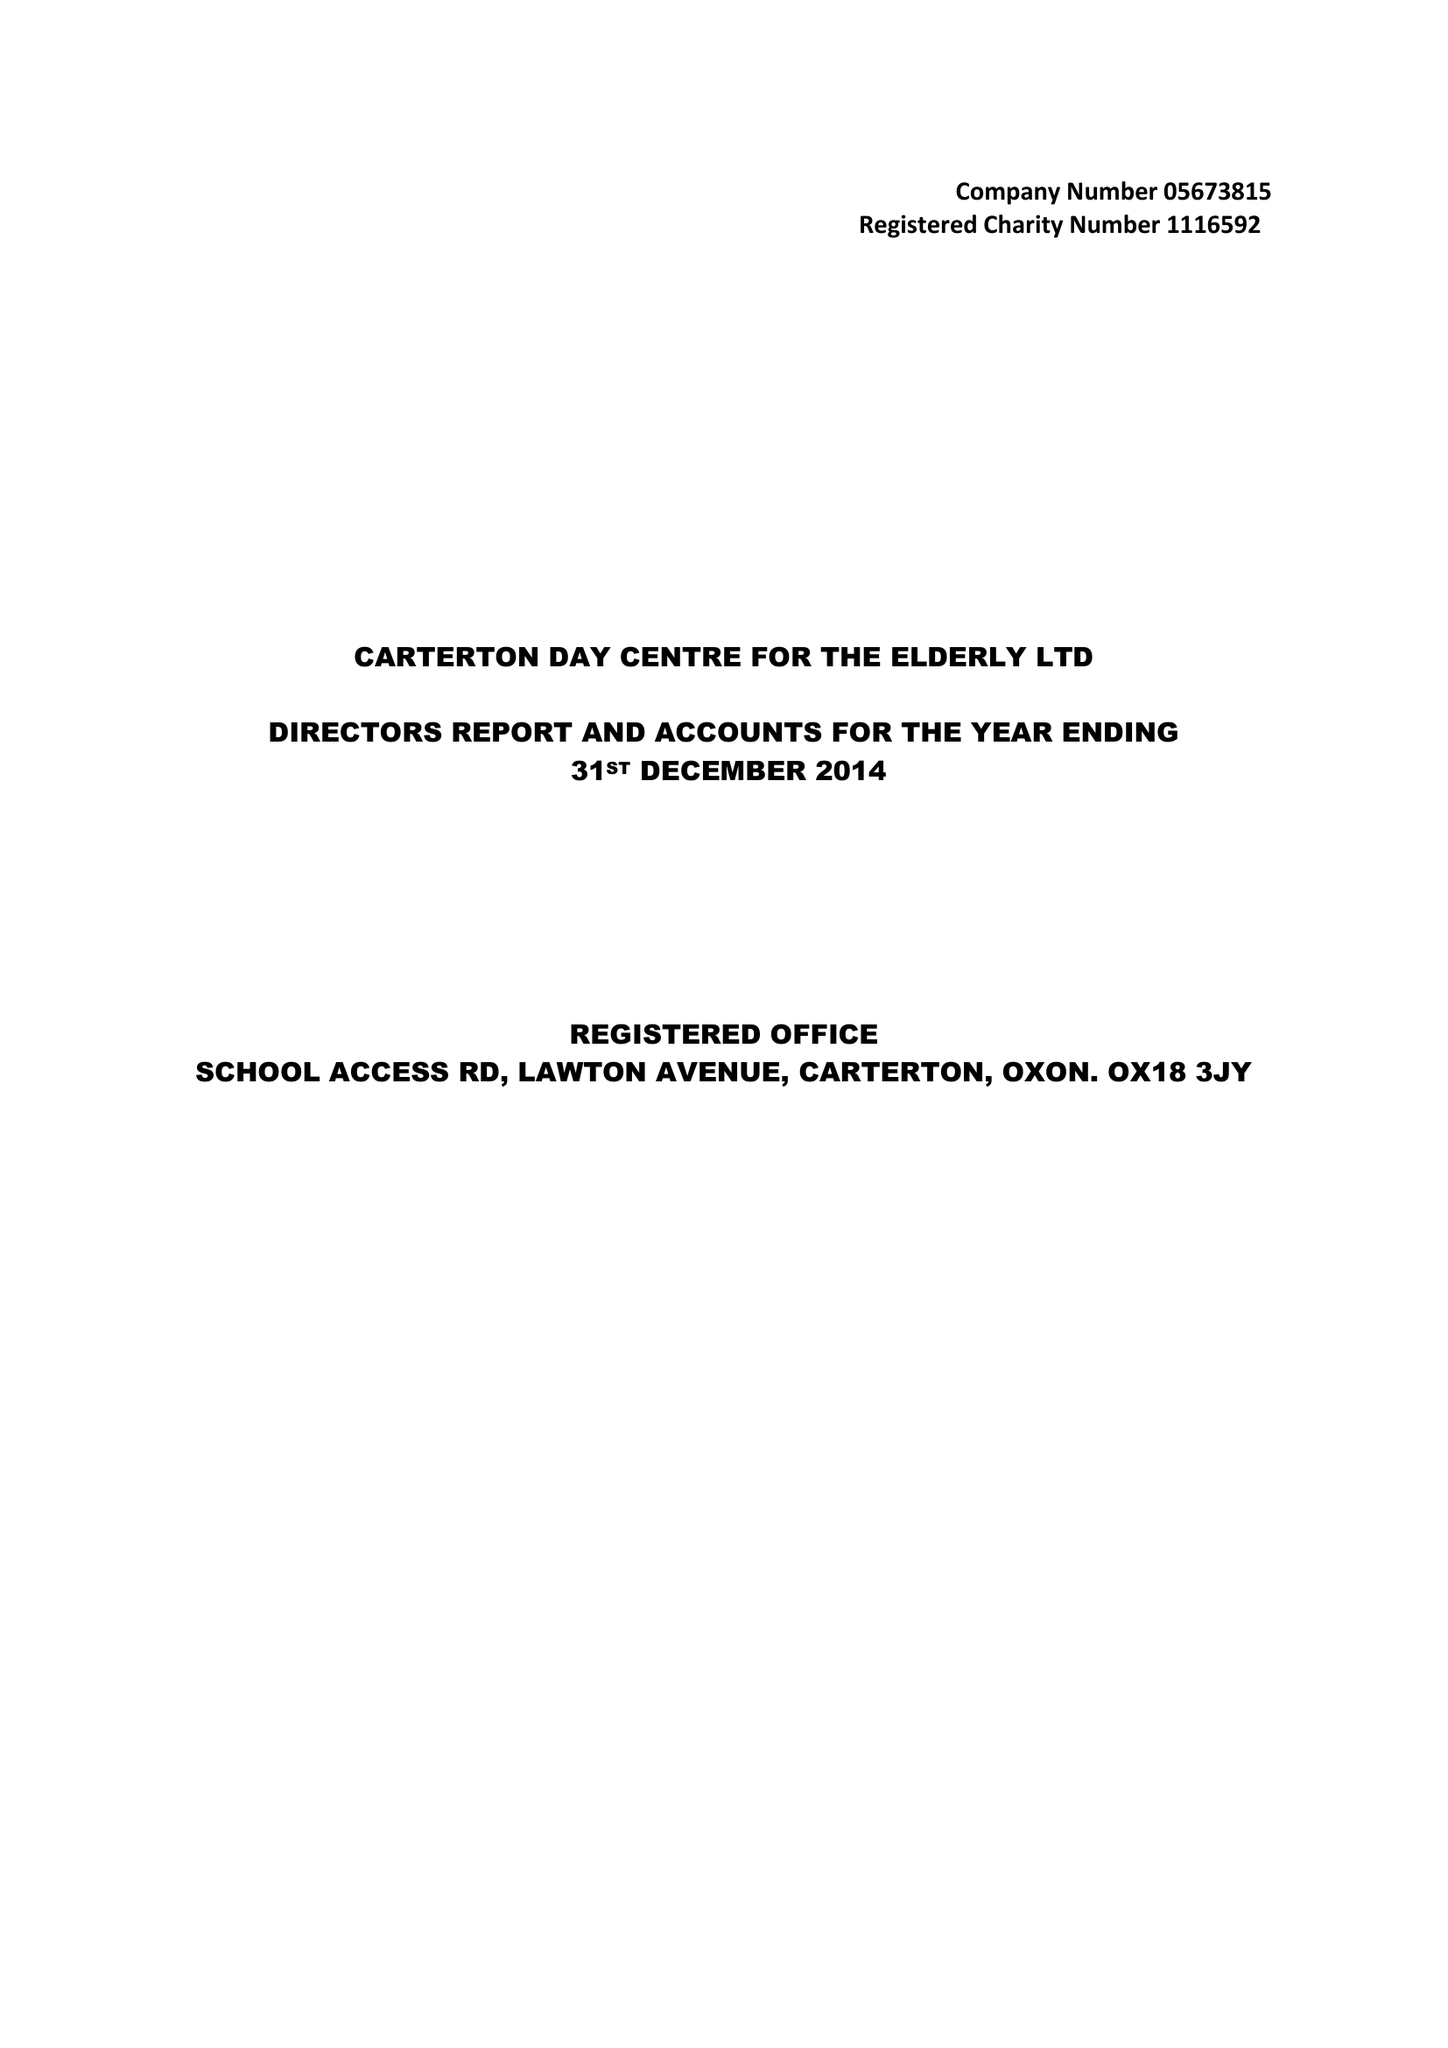What is the value for the address__postcode?
Answer the question using a single word or phrase. OX18 3JY 